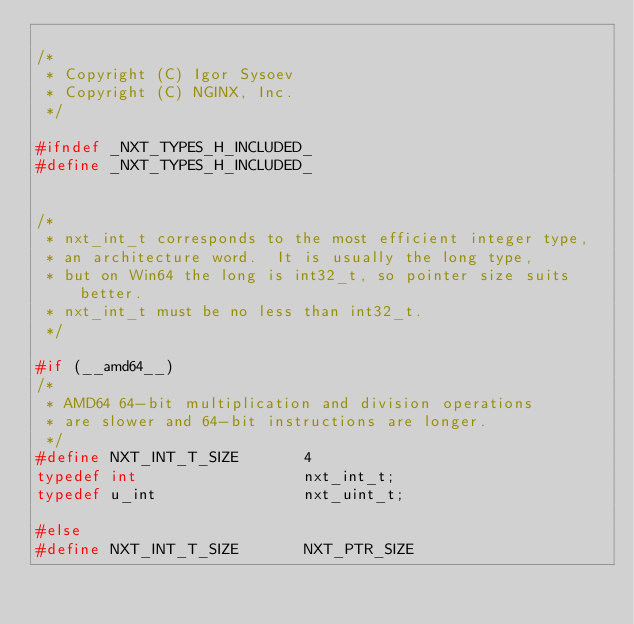<code> <loc_0><loc_0><loc_500><loc_500><_C_>
/*
 * Copyright (C) Igor Sysoev
 * Copyright (C) NGINX, Inc.
 */

#ifndef _NXT_TYPES_H_INCLUDED_
#define _NXT_TYPES_H_INCLUDED_


/*
 * nxt_int_t corresponds to the most efficient integer type,
 * an architecture word.  It is usually the long type,
 * but on Win64 the long is int32_t, so pointer size suits better.
 * nxt_int_t must be no less than int32_t.
 */

#if (__amd64__)
/*
 * AMD64 64-bit multiplication and division operations
 * are slower and 64-bit instructions are longer.
 */
#define NXT_INT_T_SIZE       4
typedef int                  nxt_int_t;
typedef u_int                nxt_uint_t;

#else
#define NXT_INT_T_SIZE       NXT_PTR_SIZE</code> 